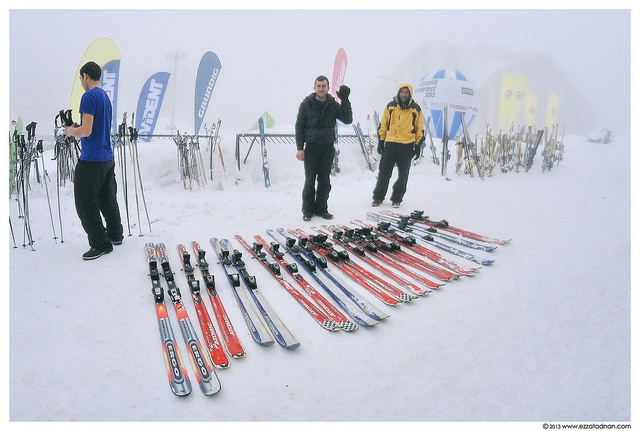Describe the objects in this image and their specific colors. I can see people in white, black, navy, blue, and darkgray tones, people in white, black, lavender, gray, and purple tones, skis in white, darkgray, gray, lightgray, and black tones, people in white, black, tan, gray, and purple tones, and skis in white, lightgray, darkgray, and gray tones in this image. 